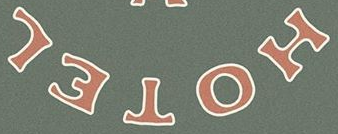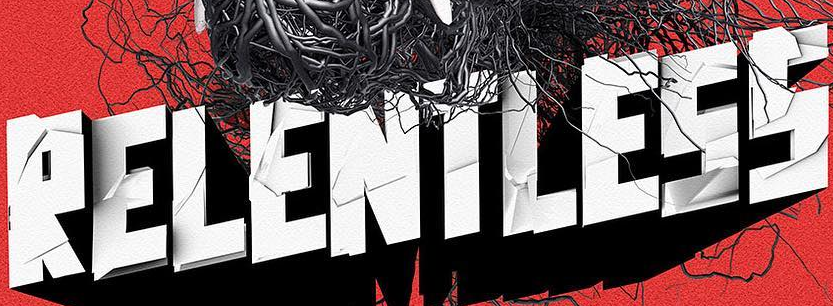What words can you see in these images in sequence, separated by a semicolon? HOTEL; RELENTLESS 